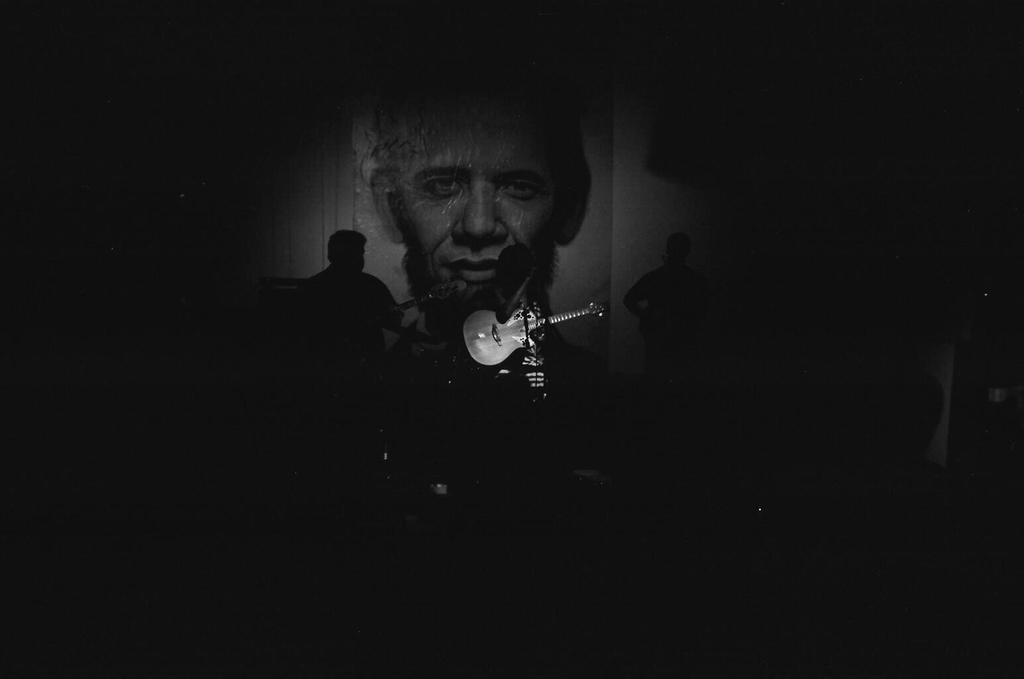What can be seen in the image? There are people standing in the image. What is the lighting like in the image? The people are standing in a dark environment. What object is visible in the image? There is a guitar visible in the image. What type of toy can be seen on the guitar in the image? There is no toy present on the guitar in the image. Is there a sink visible in the image? No, there is no sink visible in the image. 